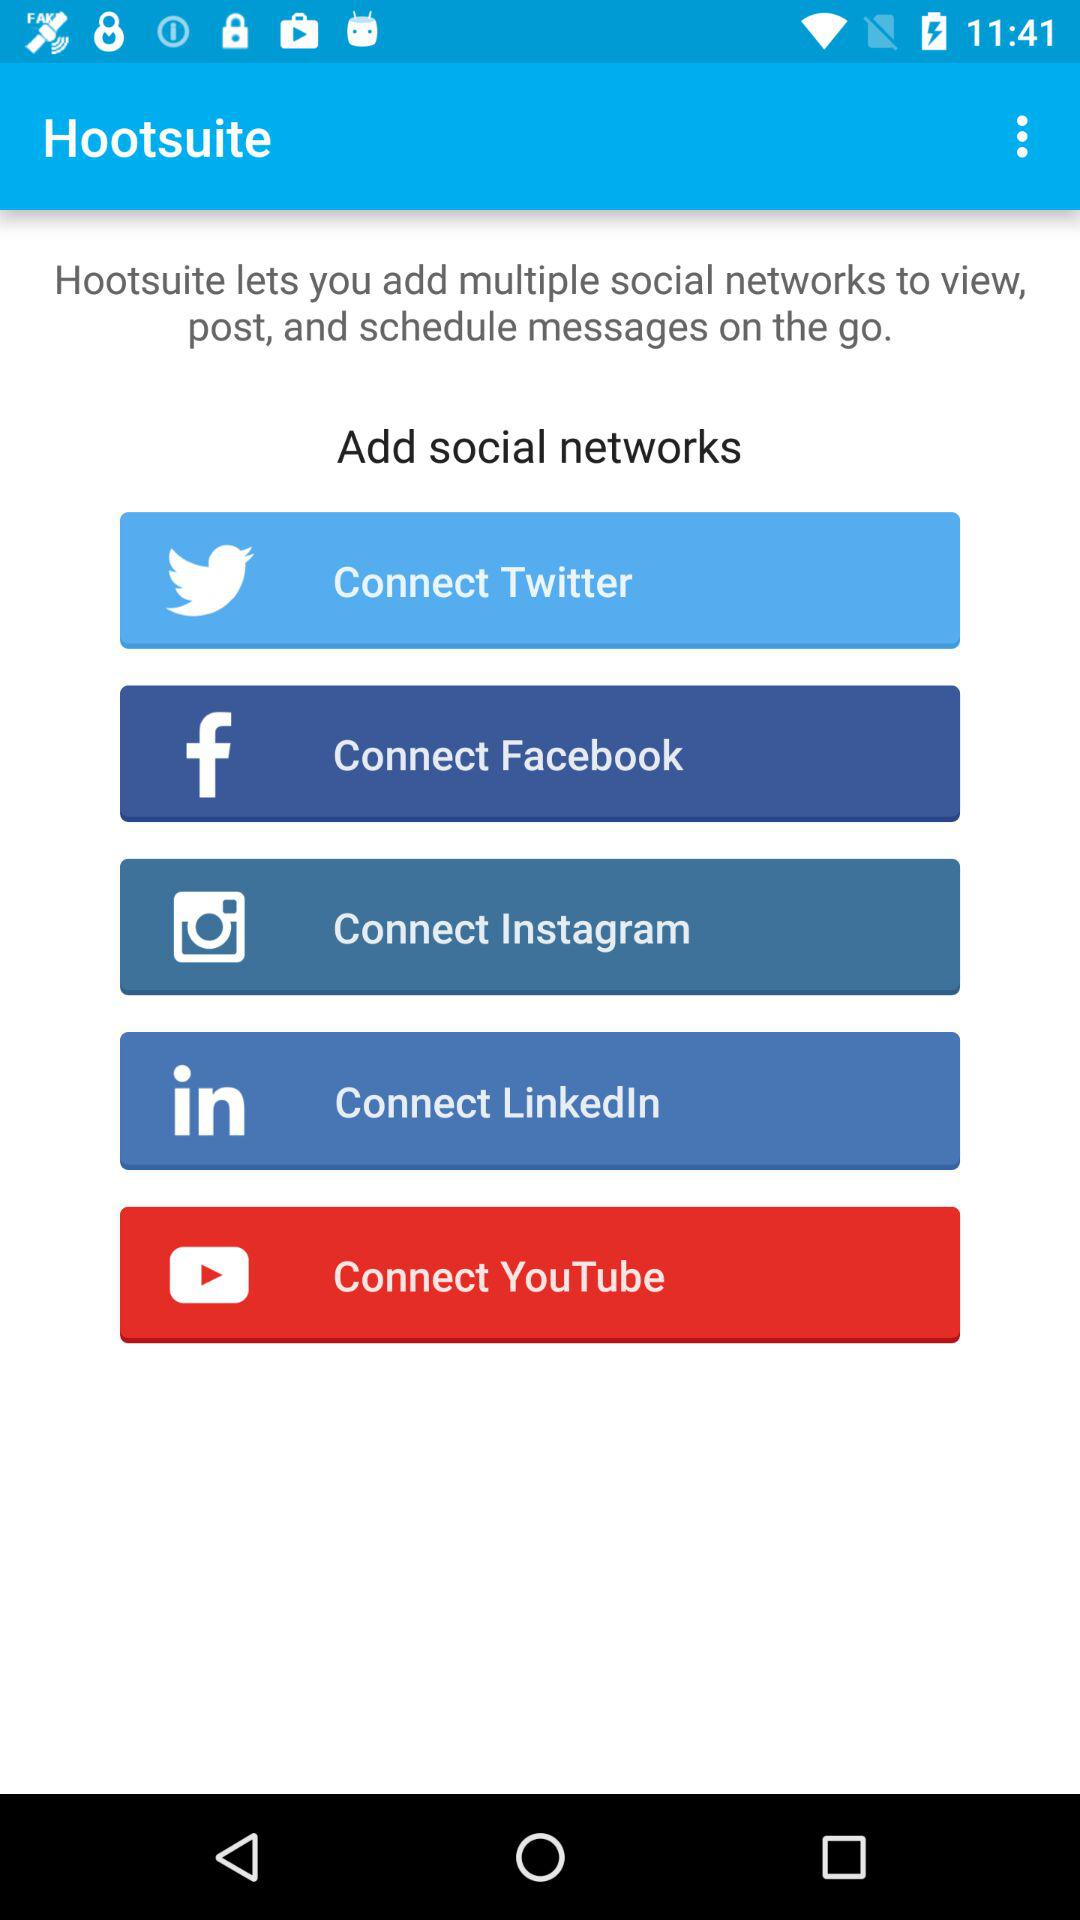Which social network application can be added? The applications "Twitter", "Facebook", "Instagram", "LinkedIn" and "YouTube" can be added. 